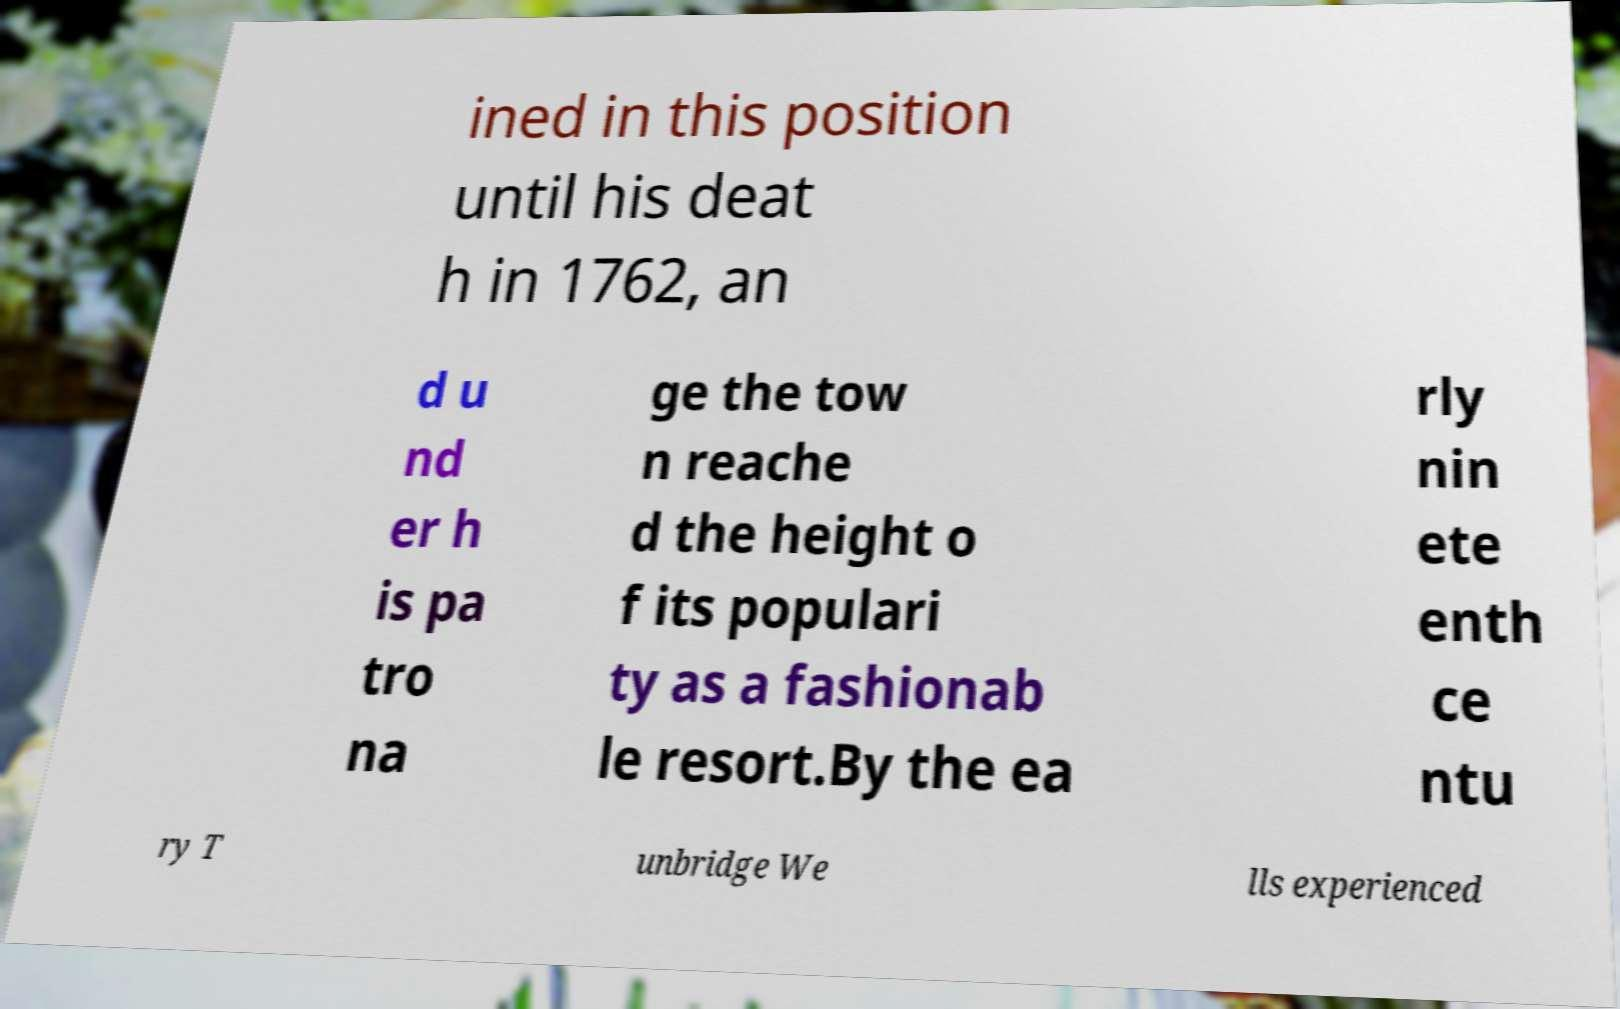There's text embedded in this image that I need extracted. Can you transcribe it verbatim? ined in this position until his deat h in 1762, an d u nd er h is pa tro na ge the tow n reache d the height o f its populari ty as a fashionab le resort.By the ea rly nin ete enth ce ntu ry T unbridge We lls experienced 